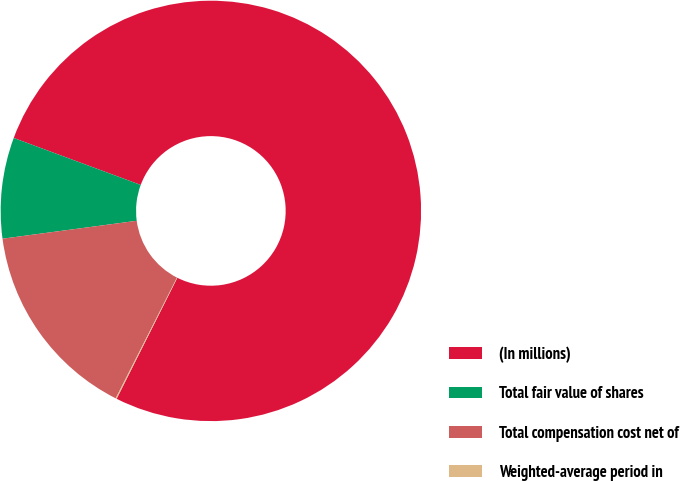Convert chart to OTSL. <chart><loc_0><loc_0><loc_500><loc_500><pie_chart><fcel>(In millions)<fcel>Total fair value of shares<fcel>Total compensation cost net of<fcel>Weighted-average period in<nl><fcel>76.76%<fcel>7.75%<fcel>15.41%<fcel>0.08%<nl></chart> 